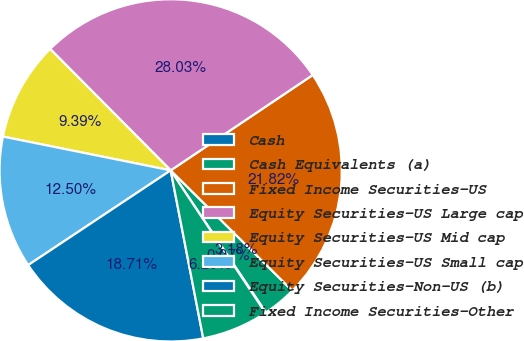Convert chart to OTSL. <chart><loc_0><loc_0><loc_500><loc_500><pie_chart><fcel>Cash<fcel>Cash Equivalents (a)<fcel>Fixed Income Securities-US<fcel>Equity Securities-US Large cap<fcel>Equity Securities-US Mid cap<fcel>Equity Securities-US Small cap<fcel>Equity Securities-Non-US (b)<fcel>Fixed Income Securities-Other<nl><fcel>0.07%<fcel>3.18%<fcel>21.82%<fcel>28.03%<fcel>9.39%<fcel>12.5%<fcel>18.71%<fcel>6.29%<nl></chart> 